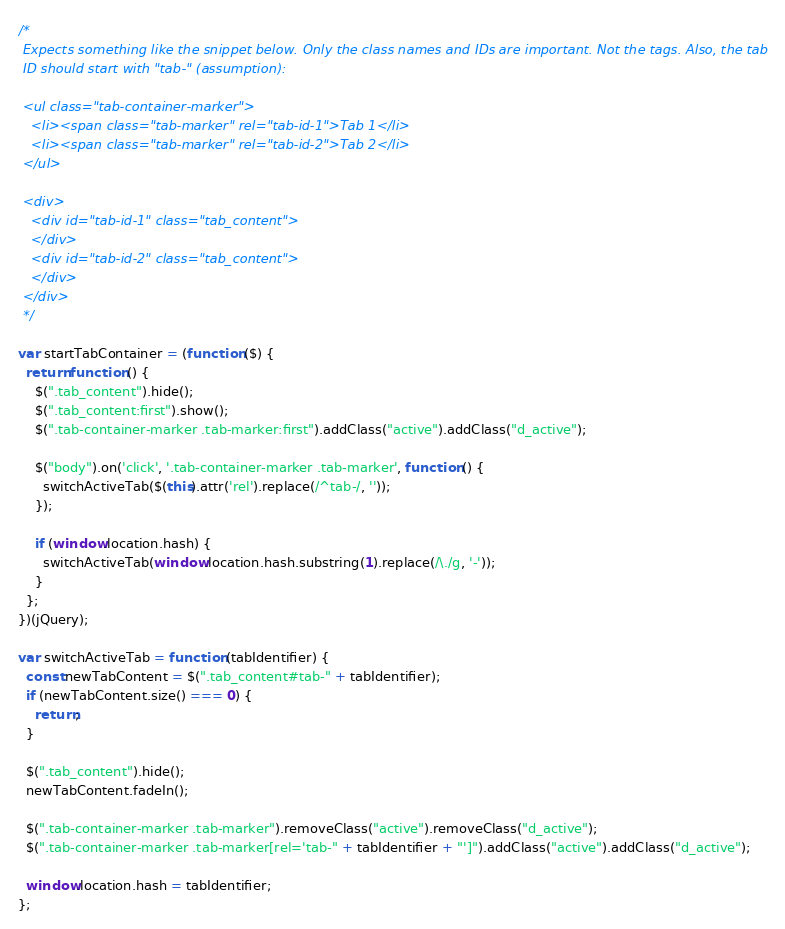Convert code to text. <code><loc_0><loc_0><loc_500><loc_500><_JavaScript_>/*
 Expects something like the snippet below. Only the class names and IDs are important. Not the tags. Also, the tab
 ID should start with "tab-" (assumption):

 <ul class="tab-container-marker">
   <li><span class="tab-marker" rel="tab-id-1">Tab 1</li>
   <li><span class="tab-marker" rel="tab-id-2">Tab 2</li>
 </ul>

 <div>
   <div id="tab-id-1" class="tab_content">
   </div>
   <div id="tab-id-2" class="tab_content">
   </div>
 </div>
 */

var startTabContainer = (function ($) {
  return function () {
    $(".tab_content").hide();
    $(".tab_content:first").show();
    $(".tab-container-marker .tab-marker:first").addClass("active").addClass("d_active");

    $("body").on('click', '.tab-container-marker .tab-marker', function () {
      switchActiveTab($(this).attr('rel').replace(/^tab-/, ''));
    });

    if (window.location.hash) {
      switchActiveTab(window.location.hash.substring(1).replace(/\./g, '-'));
    }
  };
})(jQuery);

var switchActiveTab = function (tabIdentifier) {
  const newTabContent = $(".tab_content#tab-" + tabIdentifier);
  if (newTabContent.size() === 0) {
    return;
  }

  $(".tab_content").hide();
  newTabContent.fadeIn();

  $(".tab-container-marker .tab-marker").removeClass("active").removeClass("d_active");
  $(".tab-container-marker .tab-marker[rel='tab-" + tabIdentifier + "']").addClass("active").addClass("d_active");

  window.location.hash = tabIdentifier;
};</code> 